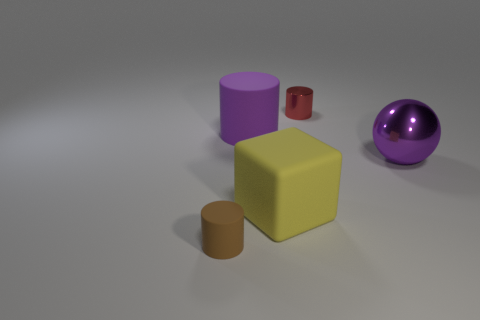Add 5 purple metal objects. How many objects exist? 10 Subtract all cylinders. How many objects are left? 2 Add 2 metallic cylinders. How many metallic cylinders are left? 3 Add 4 red things. How many red things exist? 5 Subtract 0 green cubes. How many objects are left? 5 Subtract all brown rubber cylinders. Subtract all metallic things. How many objects are left? 2 